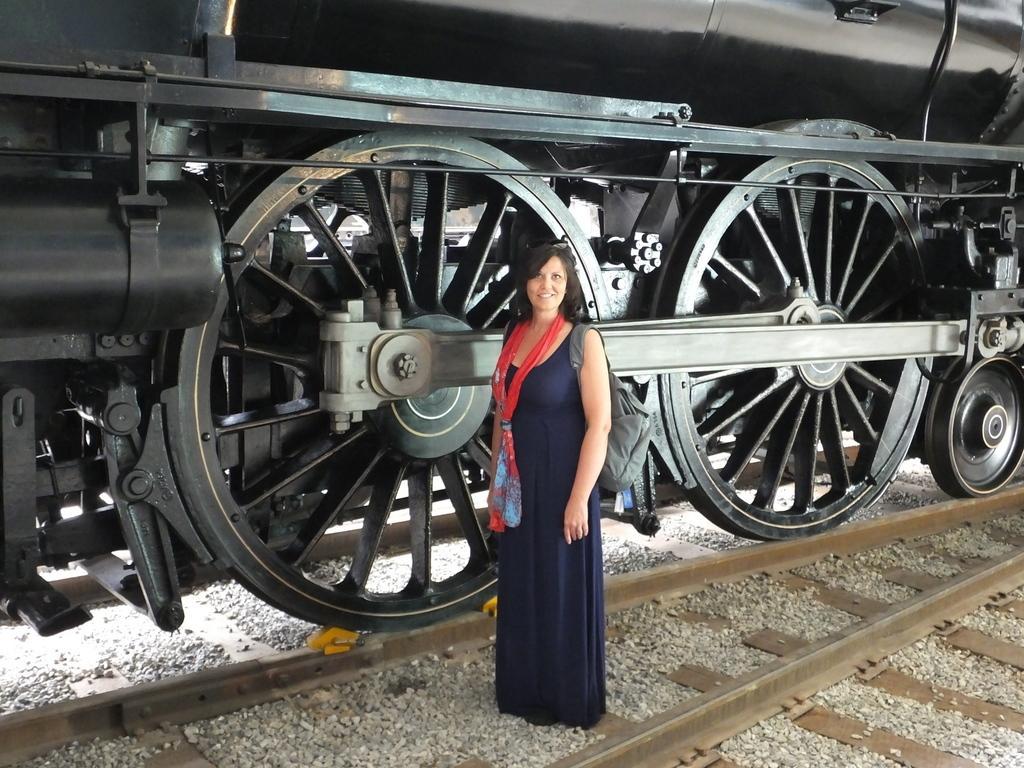Can you describe this image briefly? This picture looks like a train on the railway track and I can see a woman standing with a smile on her face and I can see a scarf and few small stones on the ground. 